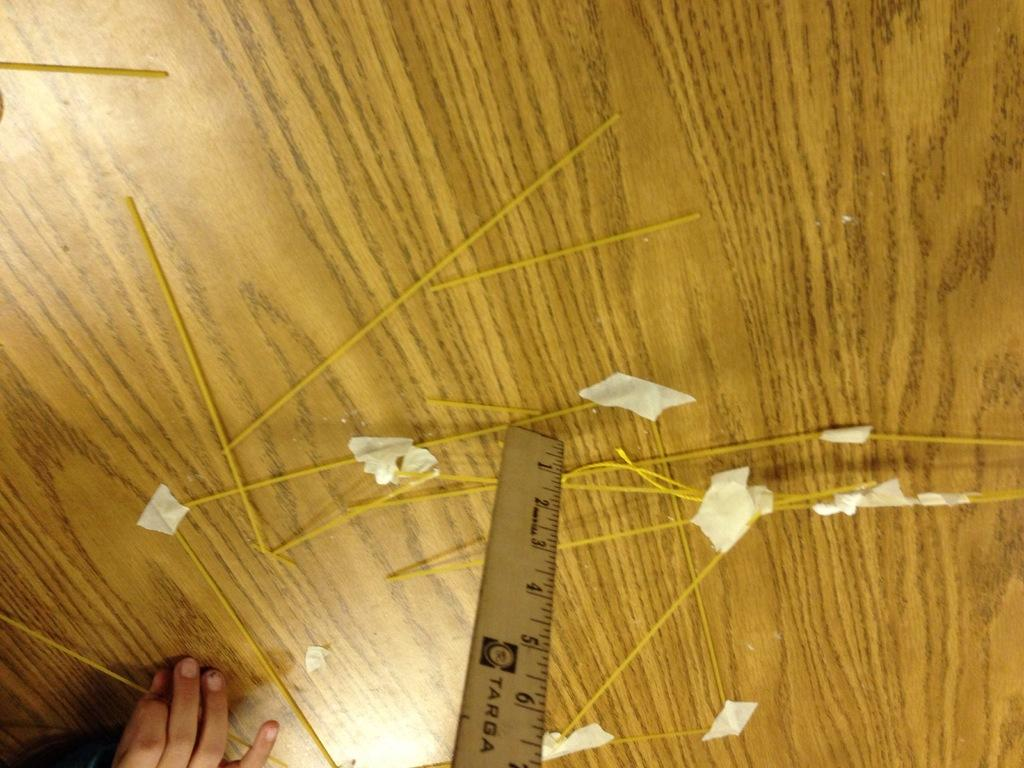<image>
Give a short and clear explanation of the subsequent image. A Tarda ruler is measuring spaghetti scattered on a table. 